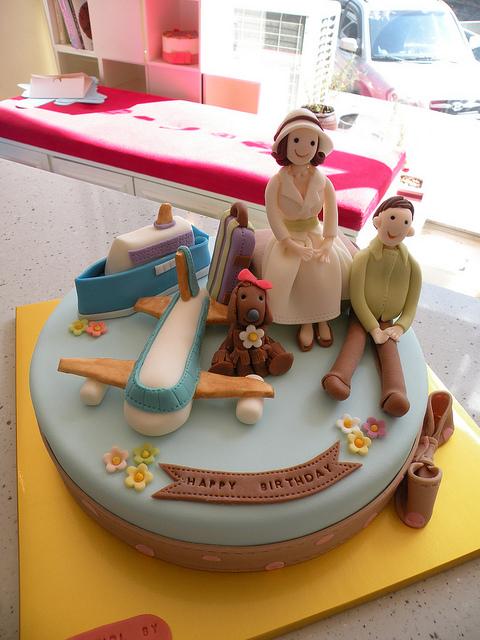What word is shown at the bottom of the cake?
Give a very brief answer. Happy birthday. Are there snowballs on the cake?
Answer briefly. No. What season is depicted on the cake?
Be succinct. Spring. What is the cake celebrating?
Give a very brief answer. Birthday. What color is the ribbon on the cake that says happy birthday?
Quick response, please. Brown. What type of flowers are on the cake?
Answer briefly. Daisy. How many dolls are on this cake?
Write a very short answer. 3. 